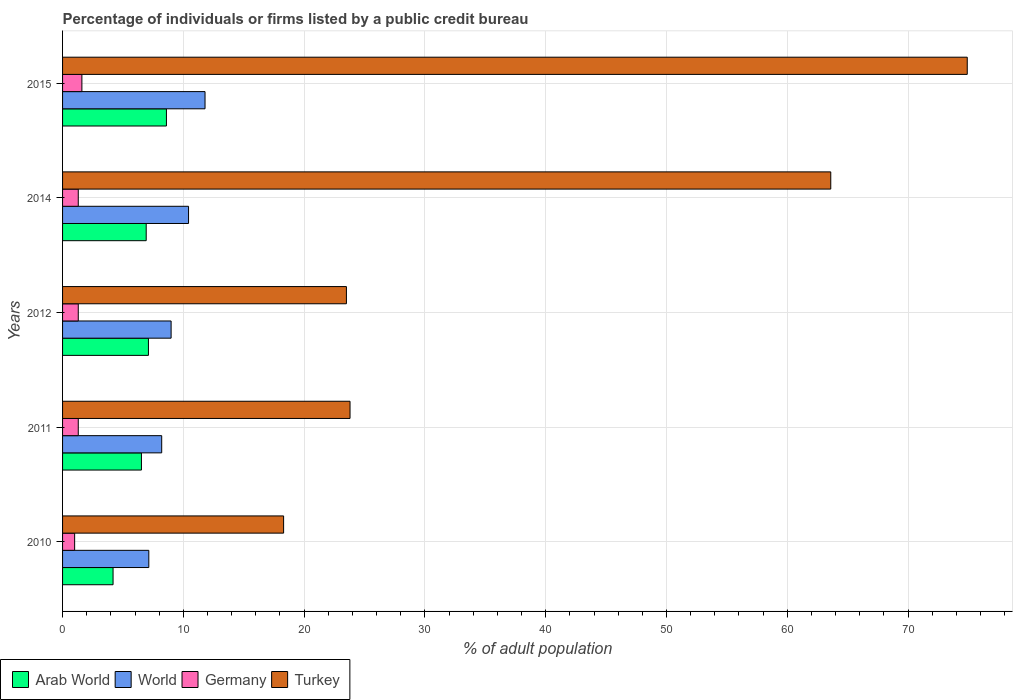How many groups of bars are there?
Make the answer very short. 5. How many bars are there on the 2nd tick from the top?
Your answer should be very brief. 4. What is the label of the 4th group of bars from the top?
Your answer should be very brief. 2011. In how many cases, is the number of bars for a given year not equal to the number of legend labels?
Offer a very short reply. 0. What is the percentage of population listed by a public credit bureau in Turkey in 2015?
Give a very brief answer. 74.9. Across all years, what is the maximum percentage of population listed by a public credit bureau in Turkey?
Ensure brevity in your answer.  74.9. In which year was the percentage of population listed by a public credit bureau in Arab World maximum?
Offer a very short reply. 2015. What is the total percentage of population listed by a public credit bureau in Arab World in the graph?
Offer a terse response. 33.34. What is the difference between the percentage of population listed by a public credit bureau in Arab World in 2010 and that in 2012?
Make the answer very short. -2.93. What is the difference between the percentage of population listed by a public credit bureau in Arab World in 2010 and the percentage of population listed by a public credit bureau in World in 2011?
Offer a terse response. -4.03. What is the average percentage of population listed by a public credit bureau in Arab World per year?
Provide a succinct answer. 6.67. In the year 2014, what is the difference between the percentage of population listed by a public credit bureau in Germany and percentage of population listed by a public credit bureau in Arab World?
Make the answer very short. -5.62. In how many years, is the percentage of population listed by a public credit bureau in Arab World greater than 22 %?
Your answer should be compact. 0. What is the ratio of the percentage of population listed by a public credit bureau in World in 2010 to that in 2012?
Keep it short and to the point. 0.79. Is the percentage of population listed by a public credit bureau in World in 2012 less than that in 2014?
Keep it short and to the point. Yes. What is the difference between the highest and the second highest percentage of population listed by a public credit bureau in Arab World?
Offer a very short reply. 1.49. What is the difference between the highest and the lowest percentage of population listed by a public credit bureau in Germany?
Your response must be concise. 0.6. Is the sum of the percentage of population listed by a public credit bureau in Turkey in 2011 and 2012 greater than the maximum percentage of population listed by a public credit bureau in Arab World across all years?
Offer a very short reply. Yes. What does the 2nd bar from the bottom in 2011 represents?
Make the answer very short. World. Is it the case that in every year, the sum of the percentage of population listed by a public credit bureau in Germany and percentage of population listed by a public credit bureau in World is greater than the percentage of population listed by a public credit bureau in Arab World?
Provide a succinct answer. Yes. How many years are there in the graph?
Make the answer very short. 5. What is the difference between two consecutive major ticks on the X-axis?
Offer a terse response. 10. Are the values on the major ticks of X-axis written in scientific E-notation?
Your answer should be compact. No. How many legend labels are there?
Provide a succinct answer. 4. What is the title of the graph?
Make the answer very short. Percentage of individuals or firms listed by a public credit bureau. What is the label or title of the X-axis?
Offer a terse response. % of adult population. What is the % of adult population in Arab World in 2010?
Provide a short and direct response. 4.18. What is the % of adult population in World in 2010?
Ensure brevity in your answer.  7.14. What is the % of adult population of Germany in 2010?
Your answer should be compact. 1. What is the % of adult population in Turkey in 2010?
Provide a succinct answer. 18.3. What is the % of adult population of Arab World in 2011?
Keep it short and to the point. 6.53. What is the % of adult population in World in 2011?
Give a very brief answer. 8.21. What is the % of adult population in Turkey in 2011?
Provide a short and direct response. 23.8. What is the % of adult population in Arab World in 2012?
Give a very brief answer. 7.11. What is the % of adult population in World in 2012?
Offer a very short reply. 8.99. What is the % of adult population in Arab World in 2014?
Offer a very short reply. 6.92. What is the % of adult population of World in 2014?
Make the answer very short. 10.43. What is the % of adult population of Turkey in 2014?
Your response must be concise. 63.6. What is the % of adult population of World in 2015?
Your answer should be very brief. 11.8. What is the % of adult population of Germany in 2015?
Your response must be concise. 1.6. What is the % of adult population in Turkey in 2015?
Provide a succinct answer. 74.9. Across all years, what is the maximum % of adult population in Arab World?
Your answer should be very brief. 8.6. Across all years, what is the maximum % of adult population of World?
Provide a short and direct response. 11.8. Across all years, what is the maximum % of adult population in Germany?
Your response must be concise. 1.6. Across all years, what is the maximum % of adult population in Turkey?
Ensure brevity in your answer.  74.9. Across all years, what is the minimum % of adult population of Arab World?
Keep it short and to the point. 4.18. Across all years, what is the minimum % of adult population in World?
Offer a very short reply. 7.14. Across all years, what is the minimum % of adult population of Turkey?
Your answer should be compact. 18.3. What is the total % of adult population in Arab World in the graph?
Provide a short and direct response. 33.34. What is the total % of adult population of World in the graph?
Your response must be concise. 46.56. What is the total % of adult population of Turkey in the graph?
Make the answer very short. 204.1. What is the difference between the % of adult population in Arab World in 2010 and that in 2011?
Offer a terse response. -2.35. What is the difference between the % of adult population of World in 2010 and that in 2011?
Provide a succinct answer. -1.07. What is the difference between the % of adult population of Germany in 2010 and that in 2011?
Your answer should be very brief. -0.3. What is the difference between the % of adult population of Turkey in 2010 and that in 2011?
Ensure brevity in your answer.  -5.5. What is the difference between the % of adult population in Arab World in 2010 and that in 2012?
Keep it short and to the point. -2.93. What is the difference between the % of adult population in World in 2010 and that in 2012?
Offer a terse response. -1.85. What is the difference between the % of adult population of Turkey in 2010 and that in 2012?
Keep it short and to the point. -5.2. What is the difference between the % of adult population in Arab World in 2010 and that in 2014?
Your answer should be very brief. -2.74. What is the difference between the % of adult population of World in 2010 and that in 2014?
Give a very brief answer. -3.29. What is the difference between the % of adult population in Turkey in 2010 and that in 2014?
Offer a very short reply. -45.3. What is the difference between the % of adult population of Arab World in 2010 and that in 2015?
Ensure brevity in your answer.  -4.42. What is the difference between the % of adult population in World in 2010 and that in 2015?
Your answer should be compact. -4.66. What is the difference between the % of adult population in Turkey in 2010 and that in 2015?
Keep it short and to the point. -56.6. What is the difference between the % of adult population of Arab World in 2011 and that in 2012?
Offer a very short reply. -0.58. What is the difference between the % of adult population in World in 2011 and that in 2012?
Your response must be concise. -0.78. What is the difference between the % of adult population of Germany in 2011 and that in 2012?
Provide a succinct answer. 0. What is the difference between the % of adult population of Arab World in 2011 and that in 2014?
Your response must be concise. -0.39. What is the difference between the % of adult population in World in 2011 and that in 2014?
Give a very brief answer. -2.22. What is the difference between the % of adult population in Turkey in 2011 and that in 2014?
Provide a short and direct response. -39.8. What is the difference between the % of adult population of Arab World in 2011 and that in 2015?
Ensure brevity in your answer.  -2.07. What is the difference between the % of adult population of World in 2011 and that in 2015?
Your answer should be compact. -3.59. What is the difference between the % of adult population in Turkey in 2011 and that in 2015?
Give a very brief answer. -51.1. What is the difference between the % of adult population of Arab World in 2012 and that in 2014?
Give a very brief answer. 0.19. What is the difference between the % of adult population in World in 2012 and that in 2014?
Your answer should be very brief. -1.44. What is the difference between the % of adult population in Germany in 2012 and that in 2014?
Your answer should be compact. 0. What is the difference between the % of adult population of Turkey in 2012 and that in 2014?
Offer a very short reply. -40.1. What is the difference between the % of adult population of Arab World in 2012 and that in 2015?
Offer a very short reply. -1.49. What is the difference between the % of adult population of World in 2012 and that in 2015?
Your response must be concise. -2.81. What is the difference between the % of adult population of Turkey in 2012 and that in 2015?
Provide a short and direct response. -51.4. What is the difference between the % of adult population in Arab World in 2014 and that in 2015?
Your answer should be compact. -1.68. What is the difference between the % of adult population in World in 2014 and that in 2015?
Your response must be concise. -1.37. What is the difference between the % of adult population of Turkey in 2014 and that in 2015?
Provide a short and direct response. -11.3. What is the difference between the % of adult population of Arab World in 2010 and the % of adult population of World in 2011?
Make the answer very short. -4.03. What is the difference between the % of adult population in Arab World in 2010 and the % of adult population in Germany in 2011?
Provide a succinct answer. 2.88. What is the difference between the % of adult population in Arab World in 2010 and the % of adult population in Turkey in 2011?
Give a very brief answer. -19.62. What is the difference between the % of adult population of World in 2010 and the % of adult population of Germany in 2011?
Make the answer very short. 5.84. What is the difference between the % of adult population of World in 2010 and the % of adult population of Turkey in 2011?
Ensure brevity in your answer.  -16.66. What is the difference between the % of adult population of Germany in 2010 and the % of adult population of Turkey in 2011?
Your answer should be compact. -22.8. What is the difference between the % of adult population of Arab World in 2010 and the % of adult population of World in 2012?
Give a very brief answer. -4.81. What is the difference between the % of adult population of Arab World in 2010 and the % of adult population of Germany in 2012?
Offer a terse response. 2.88. What is the difference between the % of adult population of Arab World in 2010 and the % of adult population of Turkey in 2012?
Give a very brief answer. -19.32. What is the difference between the % of adult population in World in 2010 and the % of adult population in Germany in 2012?
Offer a very short reply. 5.84. What is the difference between the % of adult population in World in 2010 and the % of adult population in Turkey in 2012?
Offer a terse response. -16.36. What is the difference between the % of adult population of Germany in 2010 and the % of adult population of Turkey in 2012?
Offer a terse response. -22.5. What is the difference between the % of adult population in Arab World in 2010 and the % of adult population in World in 2014?
Your response must be concise. -6.25. What is the difference between the % of adult population of Arab World in 2010 and the % of adult population of Germany in 2014?
Give a very brief answer. 2.88. What is the difference between the % of adult population in Arab World in 2010 and the % of adult population in Turkey in 2014?
Provide a succinct answer. -59.42. What is the difference between the % of adult population of World in 2010 and the % of adult population of Germany in 2014?
Offer a very short reply. 5.84. What is the difference between the % of adult population of World in 2010 and the % of adult population of Turkey in 2014?
Give a very brief answer. -56.46. What is the difference between the % of adult population of Germany in 2010 and the % of adult population of Turkey in 2014?
Offer a terse response. -62.6. What is the difference between the % of adult population of Arab World in 2010 and the % of adult population of World in 2015?
Your answer should be very brief. -7.62. What is the difference between the % of adult population of Arab World in 2010 and the % of adult population of Germany in 2015?
Give a very brief answer. 2.58. What is the difference between the % of adult population in Arab World in 2010 and the % of adult population in Turkey in 2015?
Provide a short and direct response. -70.72. What is the difference between the % of adult population in World in 2010 and the % of adult population in Germany in 2015?
Keep it short and to the point. 5.54. What is the difference between the % of adult population of World in 2010 and the % of adult population of Turkey in 2015?
Your response must be concise. -67.76. What is the difference between the % of adult population in Germany in 2010 and the % of adult population in Turkey in 2015?
Your answer should be very brief. -73.9. What is the difference between the % of adult population of Arab World in 2011 and the % of adult population of World in 2012?
Your answer should be compact. -2.46. What is the difference between the % of adult population in Arab World in 2011 and the % of adult population in Germany in 2012?
Offer a very short reply. 5.23. What is the difference between the % of adult population in Arab World in 2011 and the % of adult population in Turkey in 2012?
Keep it short and to the point. -16.97. What is the difference between the % of adult population in World in 2011 and the % of adult population in Germany in 2012?
Your response must be concise. 6.91. What is the difference between the % of adult population in World in 2011 and the % of adult population in Turkey in 2012?
Give a very brief answer. -15.29. What is the difference between the % of adult population in Germany in 2011 and the % of adult population in Turkey in 2012?
Your answer should be compact. -22.2. What is the difference between the % of adult population of Arab World in 2011 and the % of adult population of World in 2014?
Your answer should be compact. -3.9. What is the difference between the % of adult population of Arab World in 2011 and the % of adult population of Germany in 2014?
Make the answer very short. 5.23. What is the difference between the % of adult population in Arab World in 2011 and the % of adult population in Turkey in 2014?
Your response must be concise. -57.07. What is the difference between the % of adult population of World in 2011 and the % of adult population of Germany in 2014?
Offer a very short reply. 6.91. What is the difference between the % of adult population in World in 2011 and the % of adult population in Turkey in 2014?
Give a very brief answer. -55.39. What is the difference between the % of adult population of Germany in 2011 and the % of adult population of Turkey in 2014?
Ensure brevity in your answer.  -62.3. What is the difference between the % of adult population in Arab World in 2011 and the % of adult population in World in 2015?
Your answer should be compact. -5.27. What is the difference between the % of adult population in Arab World in 2011 and the % of adult population in Germany in 2015?
Your answer should be very brief. 4.93. What is the difference between the % of adult population in Arab World in 2011 and the % of adult population in Turkey in 2015?
Offer a terse response. -68.37. What is the difference between the % of adult population in World in 2011 and the % of adult population in Germany in 2015?
Offer a very short reply. 6.61. What is the difference between the % of adult population in World in 2011 and the % of adult population in Turkey in 2015?
Give a very brief answer. -66.69. What is the difference between the % of adult population in Germany in 2011 and the % of adult population in Turkey in 2015?
Ensure brevity in your answer.  -73.6. What is the difference between the % of adult population of Arab World in 2012 and the % of adult population of World in 2014?
Your response must be concise. -3.32. What is the difference between the % of adult population of Arab World in 2012 and the % of adult population of Germany in 2014?
Offer a terse response. 5.81. What is the difference between the % of adult population in Arab World in 2012 and the % of adult population in Turkey in 2014?
Offer a very short reply. -56.49. What is the difference between the % of adult population in World in 2012 and the % of adult population in Germany in 2014?
Keep it short and to the point. 7.69. What is the difference between the % of adult population in World in 2012 and the % of adult population in Turkey in 2014?
Your answer should be very brief. -54.61. What is the difference between the % of adult population of Germany in 2012 and the % of adult population of Turkey in 2014?
Your response must be concise. -62.3. What is the difference between the % of adult population of Arab World in 2012 and the % of adult population of World in 2015?
Keep it short and to the point. -4.69. What is the difference between the % of adult population in Arab World in 2012 and the % of adult population in Germany in 2015?
Your answer should be very brief. 5.51. What is the difference between the % of adult population of Arab World in 2012 and the % of adult population of Turkey in 2015?
Provide a short and direct response. -67.79. What is the difference between the % of adult population of World in 2012 and the % of adult population of Germany in 2015?
Your response must be concise. 7.39. What is the difference between the % of adult population in World in 2012 and the % of adult population in Turkey in 2015?
Make the answer very short. -65.91. What is the difference between the % of adult population in Germany in 2012 and the % of adult population in Turkey in 2015?
Ensure brevity in your answer.  -73.6. What is the difference between the % of adult population in Arab World in 2014 and the % of adult population in World in 2015?
Provide a short and direct response. -4.87. What is the difference between the % of adult population of Arab World in 2014 and the % of adult population of Germany in 2015?
Make the answer very short. 5.32. What is the difference between the % of adult population of Arab World in 2014 and the % of adult population of Turkey in 2015?
Your response must be concise. -67.98. What is the difference between the % of adult population of World in 2014 and the % of adult population of Germany in 2015?
Make the answer very short. 8.83. What is the difference between the % of adult population in World in 2014 and the % of adult population in Turkey in 2015?
Your answer should be compact. -64.47. What is the difference between the % of adult population of Germany in 2014 and the % of adult population of Turkey in 2015?
Provide a succinct answer. -73.6. What is the average % of adult population of Arab World per year?
Ensure brevity in your answer.  6.67. What is the average % of adult population of World per year?
Offer a terse response. 9.31. What is the average % of adult population of Germany per year?
Provide a succinct answer. 1.3. What is the average % of adult population of Turkey per year?
Your answer should be very brief. 40.82. In the year 2010, what is the difference between the % of adult population in Arab World and % of adult population in World?
Make the answer very short. -2.96. In the year 2010, what is the difference between the % of adult population of Arab World and % of adult population of Germany?
Your answer should be compact. 3.18. In the year 2010, what is the difference between the % of adult population in Arab World and % of adult population in Turkey?
Your answer should be compact. -14.12. In the year 2010, what is the difference between the % of adult population of World and % of adult population of Germany?
Provide a short and direct response. 6.14. In the year 2010, what is the difference between the % of adult population in World and % of adult population in Turkey?
Your answer should be very brief. -11.16. In the year 2010, what is the difference between the % of adult population of Germany and % of adult population of Turkey?
Offer a terse response. -17.3. In the year 2011, what is the difference between the % of adult population of Arab World and % of adult population of World?
Give a very brief answer. -1.68. In the year 2011, what is the difference between the % of adult population of Arab World and % of adult population of Germany?
Your response must be concise. 5.23. In the year 2011, what is the difference between the % of adult population of Arab World and % of adult population of Turkey?
Provide a succinct answer. -17.27. In the year 2011, what is the difference between the % of adult population of World and % of adult population of Germany?
Provide a succinct answer. 6.91. In the year 2011, what is the difference between the % of adult population of World and % of adult population of Turkey?
Provide a succinct answer. -15.59. In the year 2011, what is the difference between the % of adult population of Germany and % of adult population of Turkey?
Provide a short and direct response. -22.5. In the year 2012, what is the difference between the % of adult population in Arab World and % of adult population in World?
Give a very brief answer. -1.88. In the year 2012, what is the difference between the % of adult population of Arab World and % of adult population of Germany?
Provide a succinct answer. 5.81. In the year 2012, what is the difference between the % of adult population of Arab World and % of adult population of Turkey?
Your answer should be very brief. -16.39. In the year 2012, what is the difference between the % of adult population of World and % of adult population of Germany?
Provide a short and direct response. 7.69. In the year 2012, what is the difference between the % of adult population of World and % of adult population of Turkey?
Your answer should be compact. -14.51. In the year 2012, what is the difference between the % of adult population of Germany and % of adult population of Turkey?
Provide a succinct answer. -22.2. In the year 2014, what is the difference between the % of adult population of Arab World and % of adult population of World?
Offer a very short reply. -3.51. In the year 2014, what is the difference between the % of adult population of Arab World and % of adult population of Germany?
Offer a terse response. 5.62. In the year 2014, what is the difference between the % of adult population of Arab World and % of adult population of Turkey?
Make the answer very short. -56.68. In the year 2014, what is the difference between the % of adult population of World and % of adult population of Germany?
Make the answer very short. 9.13. In the year 2014, what is the difference between the % of adult population in World and % of adult population in Turkey?
Your response must be concise. -53.17. In the year 2014, what is the difference between the % of adult population in Germany and % of adult population in Turkey?
Your response must be concise. -62.3. In the year 2015, what is the difference between the % of adult population in Arab World and % of adult population in World?
Offer a terse response. -3.2. In the year 2015, what is the difference between the % of adult population in Arab World and % of adult population in Germany?
Your answer should be compact. 7. In the year 2015, what is the difference between the % of adult population of Arab World and % of adult population of Turkey?
Your response must be concise. -66.3. In the year 2015, what is the difference between the % of adult population of World and % of adult population of Germany?
Offer a very short reply. 10.2. In the year 2015, what is the difference between the % of adult population of World and % of adult population of Turkey?
Provide a short and direct response. -63.1. In the year 2015, what is the difference between the % of adult population of Germany and % of adult population of Turkey?
Your response must be concise. -73.3. What is the ratio of the % of adult population of Arab World in 2010 to that in 2011?
Ensure brevity in your answer.  0.64. What is the ratio of the % of adult population of World in 2010 to that in 2011?
Your response must be concise. 0.87. What is the ratio of the % of adult population of Germany in 2010 to that in 2011?
Ensure brevity in your answer.  0.77. What is the ratio of the % of adult population in Turkey in 2010 to that in 2011?
Your answer should be very brief. 0.77. What is the ratio of the % of adult population in Arab World in 2010 to that in 2012?
Offer a terse response. 0.59. What is the ratio of the % of adult population in World in 2010 to that in 2012?
Your response must be concise. 0.79. What is the ratio of the % of adult population of Germany in 2010 to that in 2012?
Keep it short and to the point. 0.77. What is the ratio of the % of adult population in Turkey in 2010 to that in 2012?
Your response must be concise. 0.78. What is the ratio of the % of adult population in Arab World in 2010 to that in 2014?
Your answer should be very brief. 0.6. What is the ratio of the % of adult population of World in 2010 to that in 2014?
Offer a very short reply. 0.68. What is the ratio of the % of adult population in Germany in 2010 to that in 2014?
Your response must be concise. 0.77. What is the ratio of the % of adult population in Turkey in 2010 to that in 2014?
Offer a very short reply. 0.29. What is the ratio of the % of adult population in Arab World in 2010 to that in 2015?
Offer a very short reply. 0.49. What is the ratio of the % of adult population in World in 2010 to that in 2015?
Give a very brief answer. 0.61. What is the ratio of the % of adult population of Turkey in 2010 to that in 2015?
Offer a very short reply. 0.24. What is the ratio of the % of adult population in Arab World in 2011 to that in 2012?
Your response must be concise. 0.92. What is the ratio of the % of adult population of World in 2011 to that in 2012?
Keep it short and to the point. 0.91. What is the ratio of the % of adult population of Turkey in 2011 to that in 2012?
Provide a short and direct response. 1.01. What is the ratio of the % of adult population in Arab World in 2011 to that in 2014?
Your answer should be compact. 0.94. What is the ratio of the % of adult population in World in 2011 to that in 2014?
Offer a terse response. 0.79. What is the ratio of the % of adult population of Turkey in 2011 to that in 2014?
Give a very brief answer. 0.37. What is the ratio of the % of adult population in Arab World in 2011 to that in 2015?
Give a very brief answer. 0.76. What is the ratio of the % of adult population in World in 2011 to that in 2015?
Offer a terse response. 0.7. What is the ratio of the % of adult population of Germany in 2011 to that in 2015?
Keep it short and to the point. 0.81. What is the ratio of the % of adult population of Turkey in 2011 to that in 2015?
Your answer should be very brief. 0.32. What is the ratio of the % of adult population of Arab World in 2012 to that in 2014?
Provide a succinct answer. 1.03. What is the ratio of the % of adult population of World in 2012 to that in 2014?
Offer a very short reply. 0.86. What is the ratio of the % of adult population in Germany in 2012 to that in 2014?
Your answer should be compact. 1. What is the ratio of the % of adult population of Turkey in 2012 to that in 2014?
Ensure brevity in your answer.  0.37. What is the ratio of the % of adult population of Arab World in 2012 to that in 2015?
Your answer should be very brief. 0.83. What is the ratio of the % of adult population in World in 2012 to that in 2015?
Provide a short and direct response. 0.76. What is the ratio of the % of adult population in Germany in 2012 to that in 2015?
Offer a very short reply. 0.81. What is the ratio of the % of adult population in Turkey in 2012 to that in 2015?
Your answer should be very brief. 0.31. What is the ratio of the % of adult population in Arab World in 2014 to that in 2015?
Provide a succinct answer. 0.81. What is the ratio of the % of adult population in World in 2014 to that in 2015?
Your answer should be very brief. 0.88. What is the ratio of the % of adult population in Germany in 2014 to that in 2015?
Provide a short and direct response. 0.81. What is the ratio of the % of adult population in Turkey in 2014 to that in 2015?
Provide a short and direct response. 0.85. What is the difference between the highest and the second highest % of adult population of Arab World?
Give a very brief answer. 1.49. What is the difference between the highest and the second highest % of adult population of World?
Offer a terse response. 1.37. What is the difference between the highest and the lowest % of adult population of Arab World?
Ensure brevity in your answer.  4.42. What is the difference between the highest and the lowest % of adult population in World?
Provide a short and direct response. 4.66. What is the difference between the highest and the lowest % of adult population of Germany?
Your answer should be compact. 0.6. What is the difference between the highest and the lowest % of adult population of Turkey?
Make the answer very short. 56.6. 